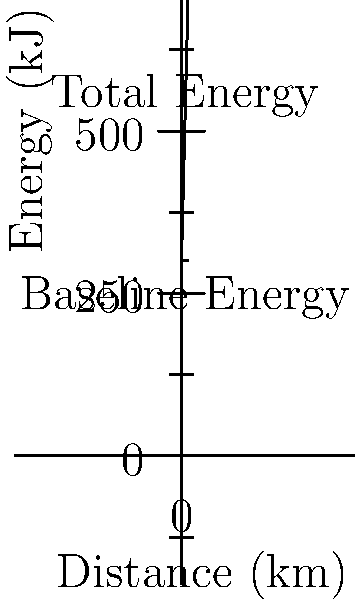During a 10 km run, a runner's total energy expenditure is represented by the function $E(x) = 300 + 40x$, where $E$ is the energy in kJ and $x$ is the distance in km. What percentage of the total energy expended at the end of the run is due to the running activity itself? To solve this problem, we'll follow these steps:

1. Calculate the total energy expended at the end of the run:
   $E(10) = 300 + 40(10) = 300 + 400 = 700$ kJ

2. Identify the baseline energy (energy expended at rest):
   This is the y-intercept of the function, which is 300 kJ.

3. Calculate the energy expended due to running:
   Running energy = Total energy - Baseline energy
   $700 - 300 = 400$ kJ

4. Calculate the percentage of energy due to running:
   Percentage = (Running energy / Total energy) × 100%
   $(400 / 700) × 100% = 0.5714 × 100% = 57.14%$

Therefore, 57.14% of the total energy expended at the end of the run is due to the running activity itself.
Answer: 57.14% 